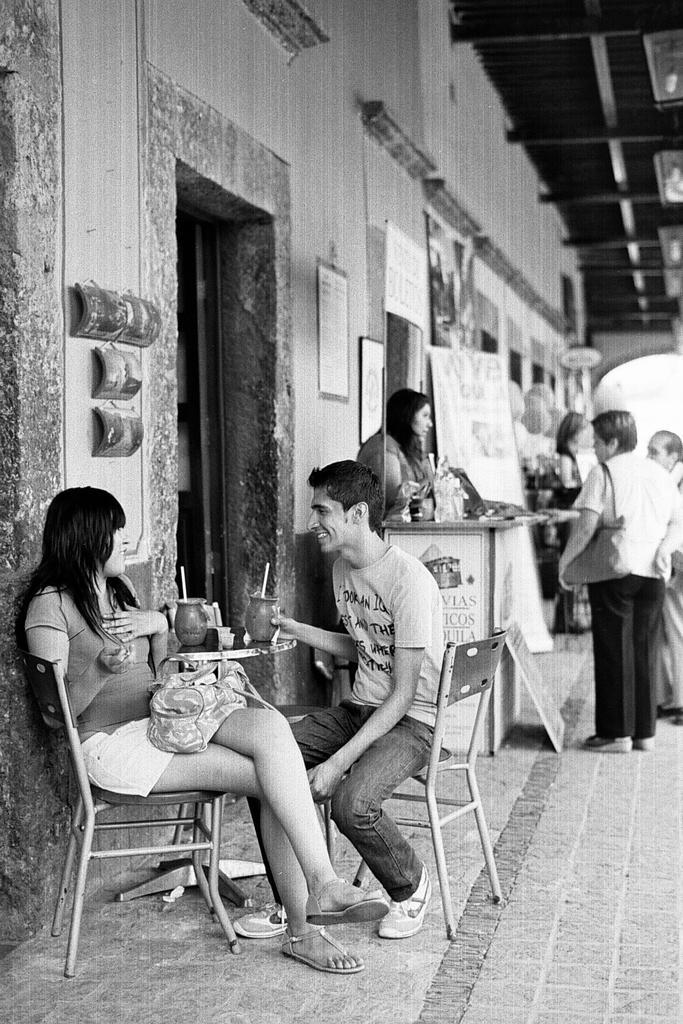In one or two sentences, can you explain what this image depicts? There are two persons sitting on the chair having their drink and there is a woman standing at the counter over here and the there are three persons at the right side of the image two of them are looking towards the counter and at the left of the image there is a wall on which there are some quotations on the wall and at the top right of the image there are lights placed at the roof. 